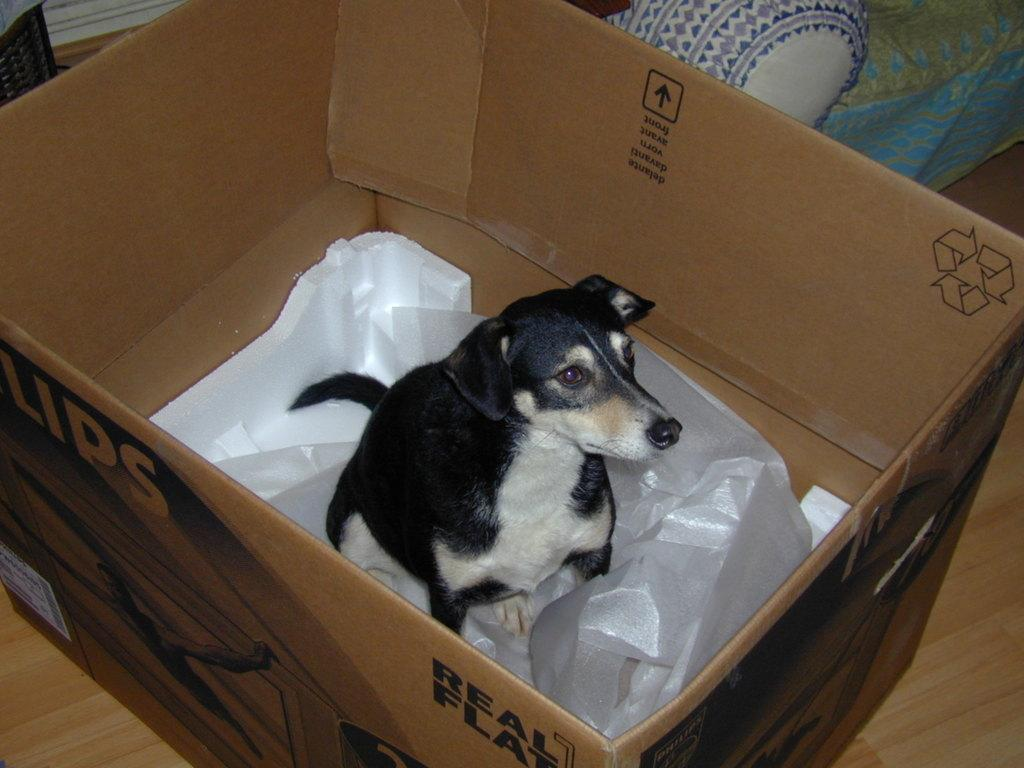What type of animal is in the image? There is a dog in the image. Where is the dog located? The dog is in a cardboard box. Can you describe the cardboard box? The cardboard box has a cover and a thermocol sheet. What can be seen in the background of the image? There is a sofa in the background of the image. What is located in the left top area of the image? There is a basket on the floor in the left top area of the image. What type of show is the dog performing at the seashore in the image? There is no show or seashore present in the image; it features a dog in a cardboard box with a cover and thermocol sheet. 